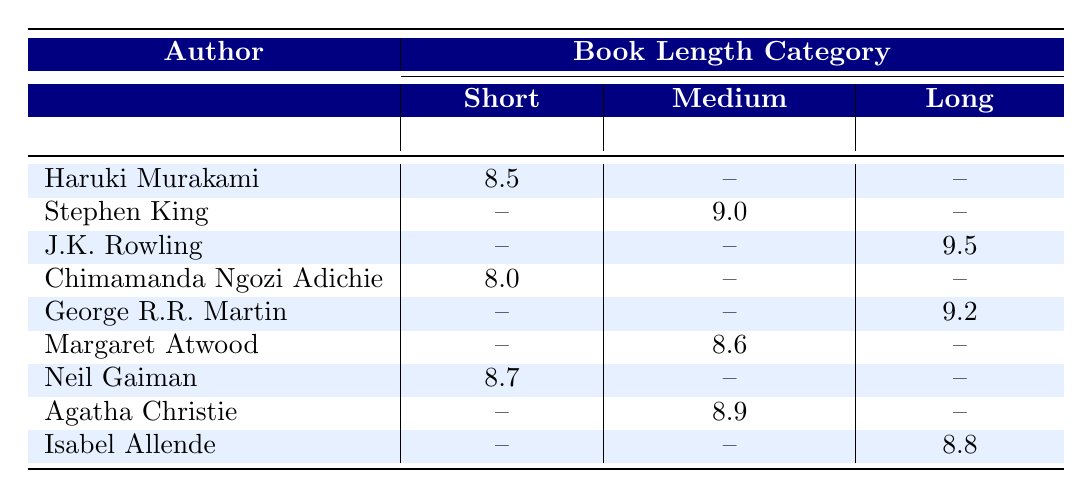What is the popularity rating of Haruki Murakami? From the table, I can see that Haruki Murakami has a popularity rating of 8.5 in the short book length category.
Answer: 8.5 Which author has the highest popularity rating in the long book length category? Looking at the long book length category, J.K. Rowling has a popularity rating of 9.5, while George R.R. Martin and Isabel Allende have ratings of 9.2 and 8.8 respectively. Thus, J.K. Rowling has the highest rating in this category.
Answer: J.K. Rowling Is there an author in the medium book length category with a popularity rating below 9.0? Analyzing the medium category, Margaret Atwood has a rating of 8.6 and Agatha Christie has a rating of 8.9. Both of these ratings are below 9.0, confirming that there are indeed authors with lower ratings.
Answer: Yes What is the average popularity rating of authors in the short book length category? The popularity ratings in the short category are 8.5 (Haruki Murakami), 8.0 (Chimamanda Ngozi Adichie), and 8.7 (Neil Gaiman). Adding these gives us 8.5 + 8.0 + 8.7 = 25.2. Dividing by 3 (the number of authors) results in an average of 25.2/3 = 8.4.
Answer: 8.4 Which author has the lowest popularity rating among those with short books? In the short book category, the ratings are 8.5 (Haruki Murakami), 8.0 (Chimamanda Ngozi Adichie), and 8.7 (Neil Gaiman). Comparing these, the lowest rating is clearly 8.0 belonging to Chimamanda Ngozi Adichie.
Answer: Chimamanda Ngozi Adichie 